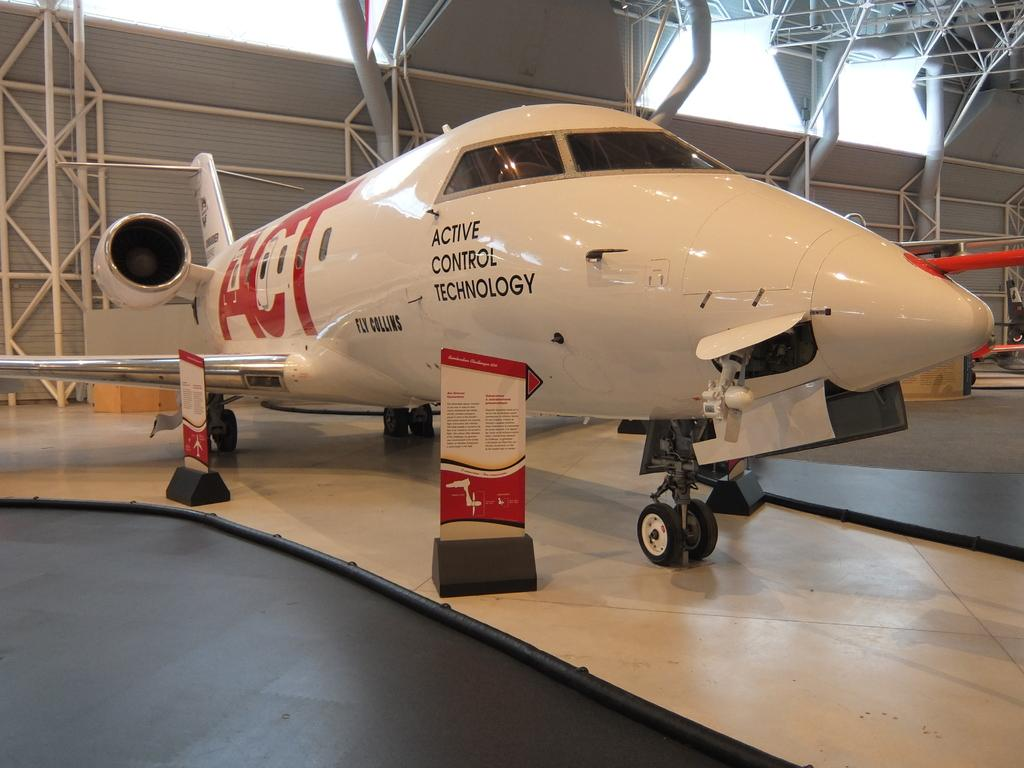What is the main subject of the image? There is an aeroplane in the center of the image. What can be seen in the background of the image? There are iron rods and a wall in the background of the image. What level of the building is the aeroplane on in the image? The image does not depict a building with multiple levels, and the aeroplane is not on any level of a building. What country is the aeroplane flying over in the image? The image does not provide any information about the country or location where the aeroplane is flying. 